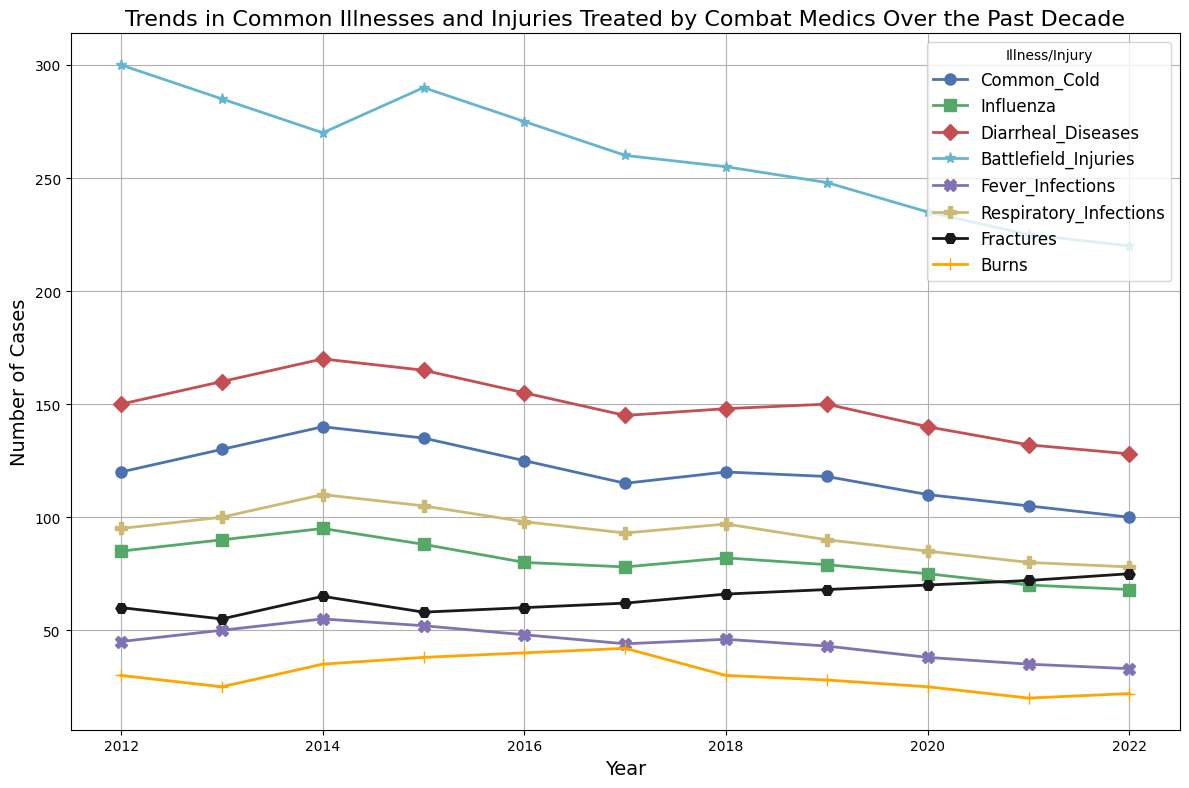What is the trend in the number of Common Cold cases over the past decade? First, look at the line representing Common Cold cases which is marked in a specific color and style. Then, observe its general direction over time from 2012 to 2022. You will notice that the number generally decreases over these years.
Answer: Decreasing Which illness had the highest number of cases in 2014? Find the year 2014 along the x-axis and then look upwards to see which line reaches the highest point in this year. The corresponding label of this line will be the illness with the highest cases.
Answer: Battlefield Injuries How many more cases of Influenza were there in 2013 compared to 2022? Find the number of Influenza cases for both 2013 and 2022 from the graph. Subtract the number of cases in 2022 from the number in 2013 to get the difference.
Answer: 22 What was the peak number of Respiratory Infections, and in which year did it occur? Identify the line representing Respiratory Infections by its color and marker. Trace this line to find its highest point and note the corresponding year.
Answer: 110 in 2014 Compare the trends in Diarrheal Diseases and Fever Infections. Which one decreased more significantly over the decade? Observe and compare the overall slopes of the lines representing Diarrheal Diseases and Fever Infections. Determine which line shows a steeper decline from 2012 to 2022.
Answer: Fever Infections What is the average number of Burns cases over the entire decade? Sum up all the data points for Burns cases from 2012 to 2022 and then divide by the number of years, which is 11.
Answer: 30.27 (rounded) Which illness or injury shows a relatively stable trend without large fluctuations over the decade? Identify the line that demonstrates minimal up and down movements over time, indicating stability in the number of cases.
Answer: Respiratory Infections How does the number of Fractures in 2015 compare to the number in 2022? Locate the data points for Fractures in 2015 and 2022 and compare their values directly to see which year had more cases.
Answer: Fewer in 2015 What is the total number of cases treated for Battlefield Injuries from 2012 to 2022? Sum the number of Battlefield Injuries for each year from the dataset provided, from 2012 to 2022.
Answer: 2868 